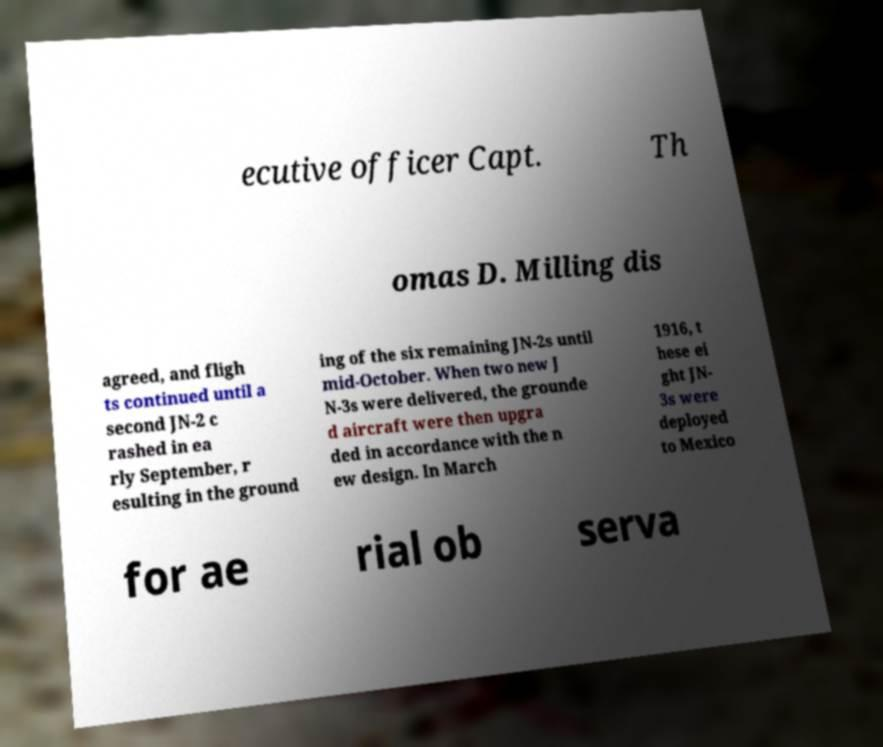For documentation purposes, I need the text within this image transcribed. Could you provide that? ecutive officer Capt. Th omas D. Milling dis agreed, and fligh ts continued until a second JN-2 c rashed in ea rly September, r esulting in the ground ing of the six remaining JN-2s until mid-October. When two new J N-3s were delivered, the grounde d aircraft were then upgra ded in accordance with the n ew design. In March 1916, t hese ei ght JN- 3s were deployed to Mexico for ae rial ob serva 